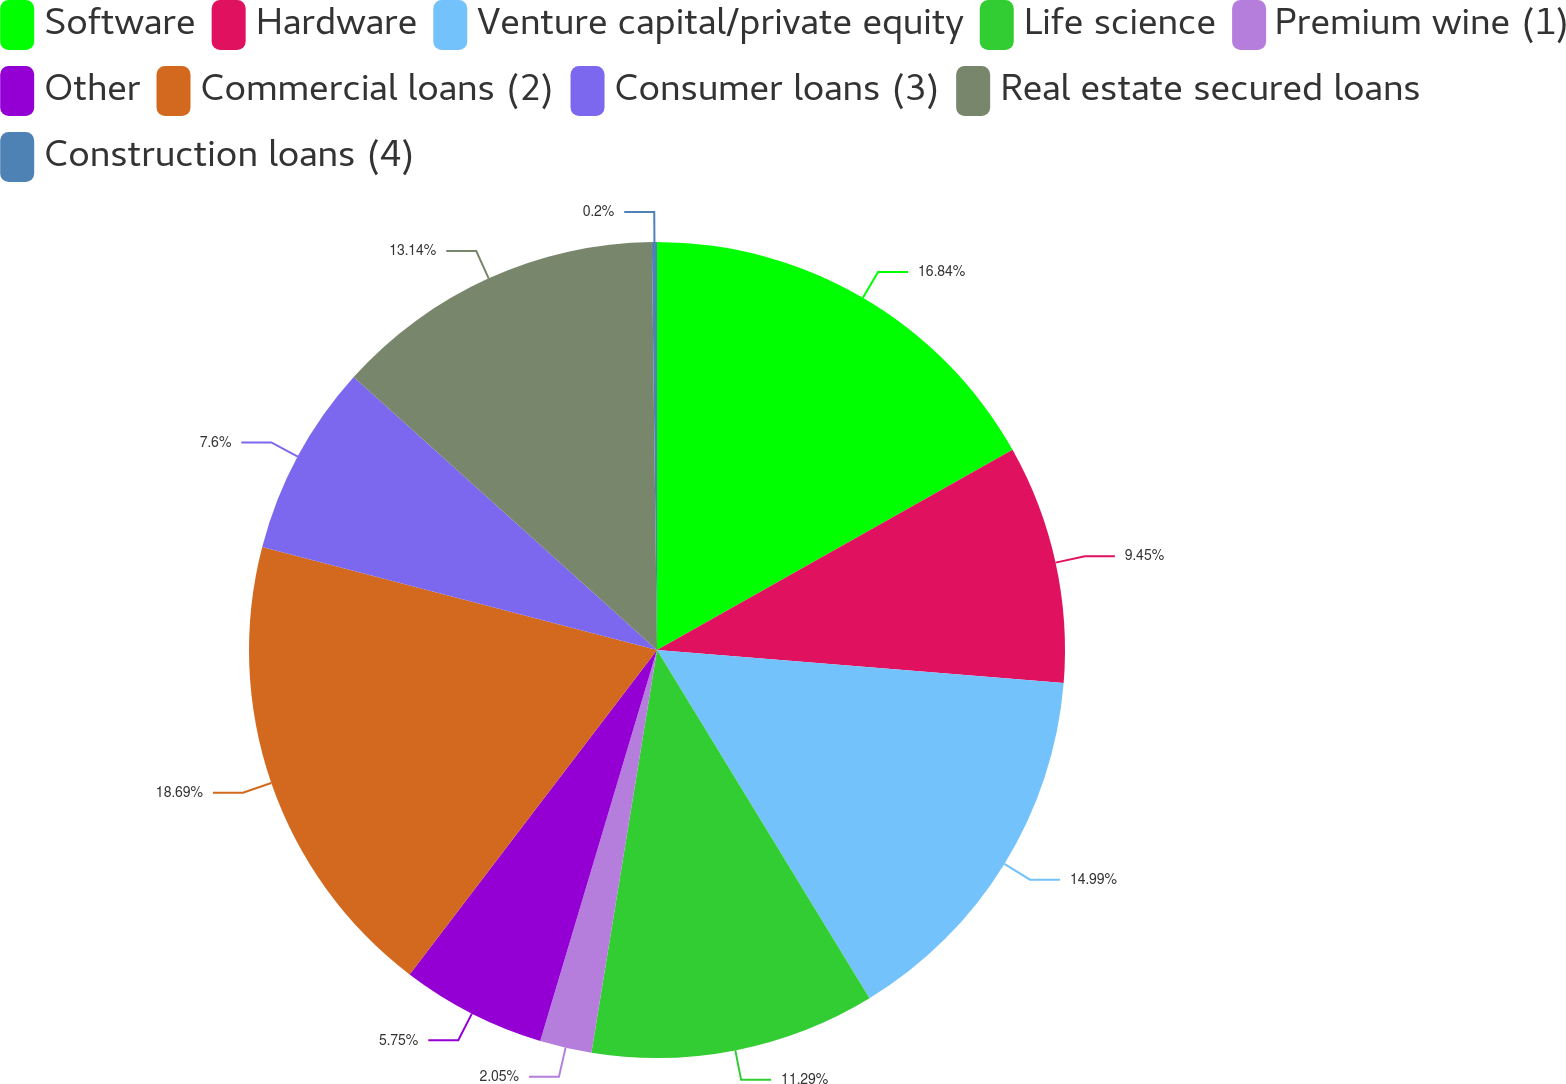Convert chart to OTSL. <chart><loc_0><loc_0><loc_500><loc_500><pie_chart><fcel>Software<fcel>Hardware<fcel>Venture capital/private equity<fcel>Life science<fcel>Premium wine (1)<fcel>Other<fcel>Commercial loans (2)<fcel>Consumer loans (3)<fcel>Real estate secured loans<fcel>Construction loans (4)<nl><fcel>16.84%<fcel>9.45%<fcel>14.99%<fcel>11.29%<fcel>2.05%<fcel>5.75%<fcel>18.69%<fcel>7.6%<fcel>13.14%<fcel>0.2%<nl></chart> 